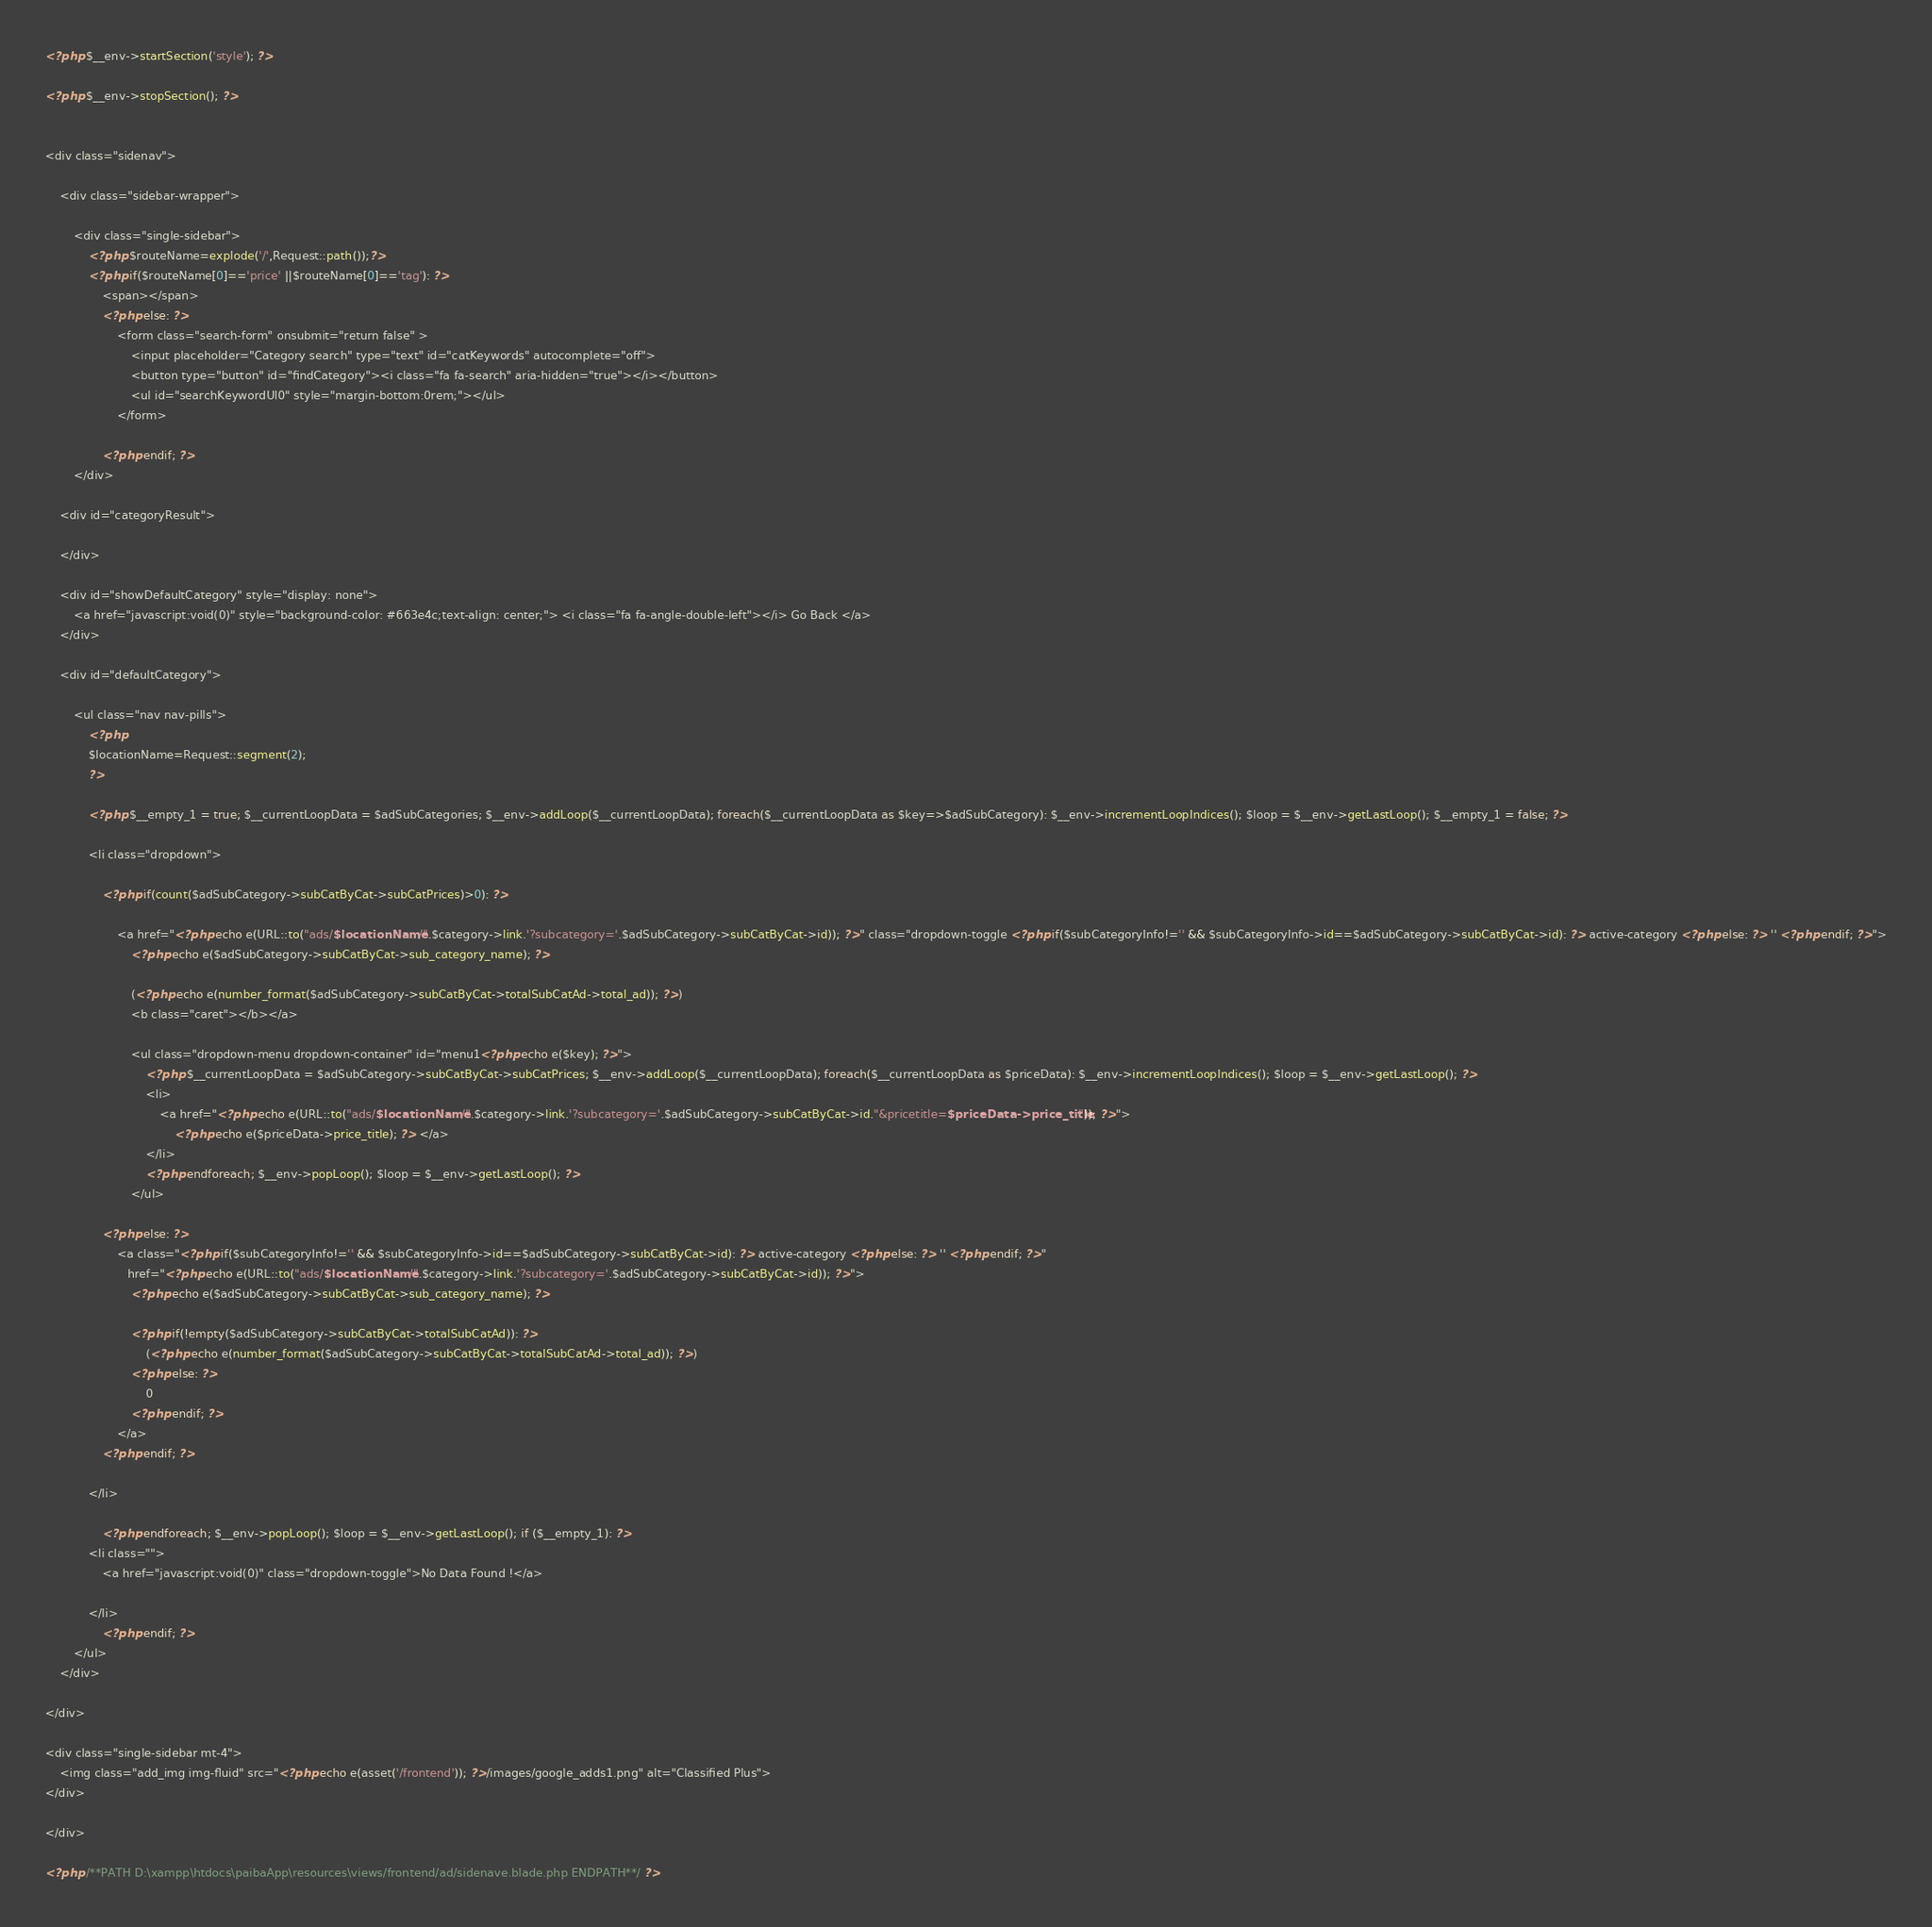<code> <loc_0><loc_0><loc_500><loc_500><_PHP_><?php $__env->startSection('style'); ?>

<?php $__env->stopSection(); ?>


<div class="sidenav">

    <div class="sidebar-wrapper">

        <div class="single-sidebar">
            <?php $routeName=explode('/',Request::path());?>
            <?php if($routeName[0]=='price' ||$routeName[0]=='tag'): ?>
                <span></span>
                <?php else: ?>
                    <form class="search-form" onsubmit="return false" >
                        <input placeholder="Category search" type="text" id="catKeywords" autocomplete="off">
                        <button type="button" id="findCategory"><i class="fa fa-search" aria-hidden="true"></i></button>
                        <ul id="searchKeywordUl0" style="margin-bottom:0rem;"></ul>
                    </form>

                <?php endif; ?>
        </div>

    <div id="categoryResult">

    </div>

    <div id="showDefaultCategory" style="display: none">
        <a href="javascript:void(0)" style="background-color: #663e4c;text-align: center;"> <i class="fa fa-angle-double-left"></i> Go Back </a>
    </div>

    <div id="defaultCategory">

        <ul class="nav nav-pills">
            <?php
            $locationName=Request::segment(2);
            ?>

            <?php $__empty_1 = true; $__currentLoopData = $adSubCategories; $__env->addLoop($__currentLoopData); foreach($__currentLoopData as $key=>$adSubCategory): $__env->incrementLoopIndices(); $loop = $__env->getLastLoop(); $__empty_1 = false; ?>

            <li class="dropdown">

                <?php if(count($adSubCategory->subCatByCat->subCatPrices)>0): ?>

                    <a href="<?php echo e(URL::to("ads/$locationName/".$category->link.'?subcategory='.$adSubCategory->subCatByCat->id)); ?>" class="dropdown-toggle <?php if($subCategoryInfo!='' && $subCategoryInfo->id==$adSubCategory->subCatByCat->id): ?> active-category <?php else: ?> '' <?php endif; ?>">
                        <?php echo e($adSubCategory->subCatByCat->sub_category_name); ?>

                        (<?php echo e(number_format($adSubCategory->subCatByCat->totalSubCatAd->total_ad)); ?>)
                        <b class="caret"></b></a>

                        <ul class="dropdown-menu dropdown-container" id="menu1<?php echo e($key); ?>">
                            <?php $__currentLoopData = $adSubCategory->subCatByCat->subCatPrices; $__env->addLoop($__currentLoopData); foreach($__currentLoopData as $priceData): $__env->incrementLoopIndices(); $loop = $__env->getLastLoop(); ?>
                            <li>
                                <a href="<?php echo e(URL::to("ads/$locationName/".$category->link.'?subcategory='.$adSubCategory->subCatByCat->id."&pricetitle=$priceData->price_title")); ?>">
                                    <?php echo e($priceData->price_title); ?> </a>
                            </li>
                            <?php endforeach; $__env->popLoop(); $loop = $__env->getLastLoop(); ?>
                        </ul>

                <?php else: ?>
                    <a class="<?php if($subCategoryInfo!='' && $subCategoryInfo->id==$adSubCategory->subCatByCat->id): ?> active-category <?php else: ?> '' <?php endif; ?>"
                       href="<?php echo e(URL::to("ads/$locationName/".$category->link.'?subcategory='.$adSubCategory->subCatByCat->id)); ?>">
                        <?php echo e($adSubCategory->subCatByCat->sub_category_name); ?>

                        <?php if(!empty($adSubCategory->subCatByCat->totalSubCatAd)): ?>
                            (<?php echo e(number_format($adSubCategory->subCatByCat->totalSubCatAd->total_ad)); ?>)
                        <?php else: ?>
                            0
                        <?php endif; ?>
                    </a>
                <?php endif; ?>

            </li>

                <?php endforeach; $__env->popLoop(); $loop = $__env->getLastLoop(); if ($__empty_1): ?>
            <li class="">
                <a href="javascript:void(0)" class="dropdown-toggle">No Data Found !</a>

            </li>
                <?php endif; ?>
        </ul>
    </div>

</div>

<div class="single-sidebar mt-4">
    <img class="add_img img-fluid" src="<?php echo e(asset('/frontend')); ?>/images/google_adds1.png" alt="Classified Plus">
</div>

</div>

<?php /**PATH D:\xampp\htdocs\paibaApp\resources\views/frontend/ad/sidenave.blade.php ENDPATH**/ ?></code> 